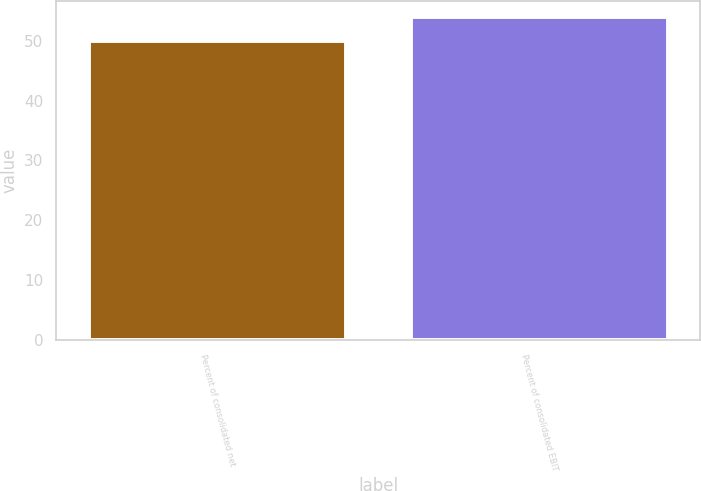<chart> <loc_0><loc_0><loc_500><loc_500><bar_chart><fcel>Percent of consolidated net<fcel>Percent of consolidated EBIT<nl><fcel>50<fcel>54<nl></chart> 